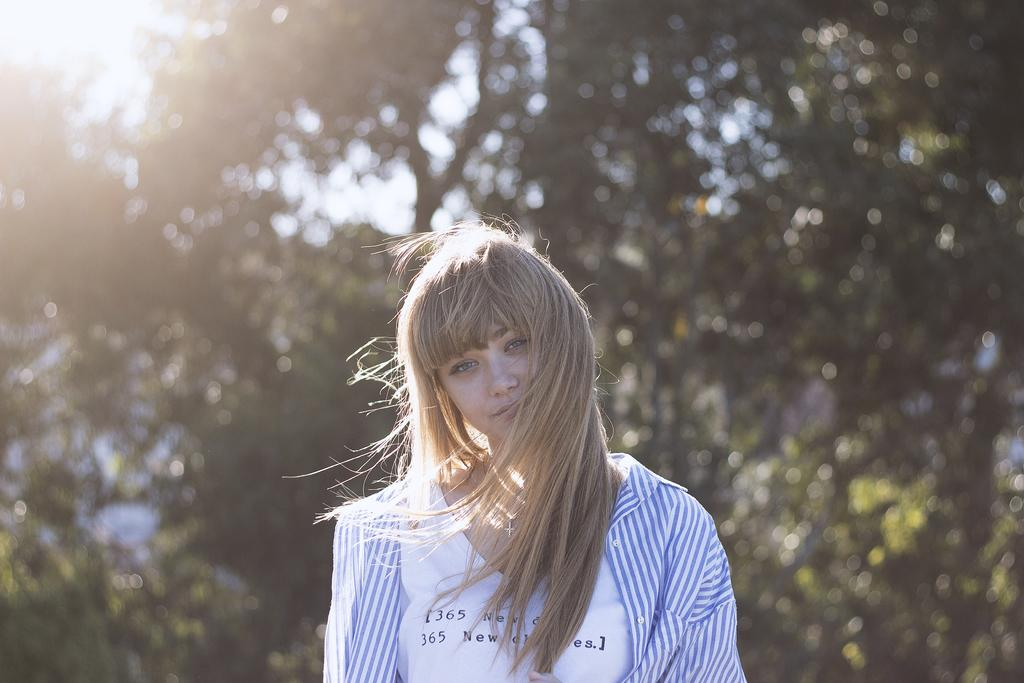Who is the main subject in the image? There is a woman in the front of the image. What can be seen in the background of the image? There are trees in the background of the image. What part of the natural environment is visible in the image? The sky is visible at the top left of the image. What type of coal is being used to wash the woman's clothes in the image? There is no coal or washing activity present in the image; it features a woman and trees in the background. 